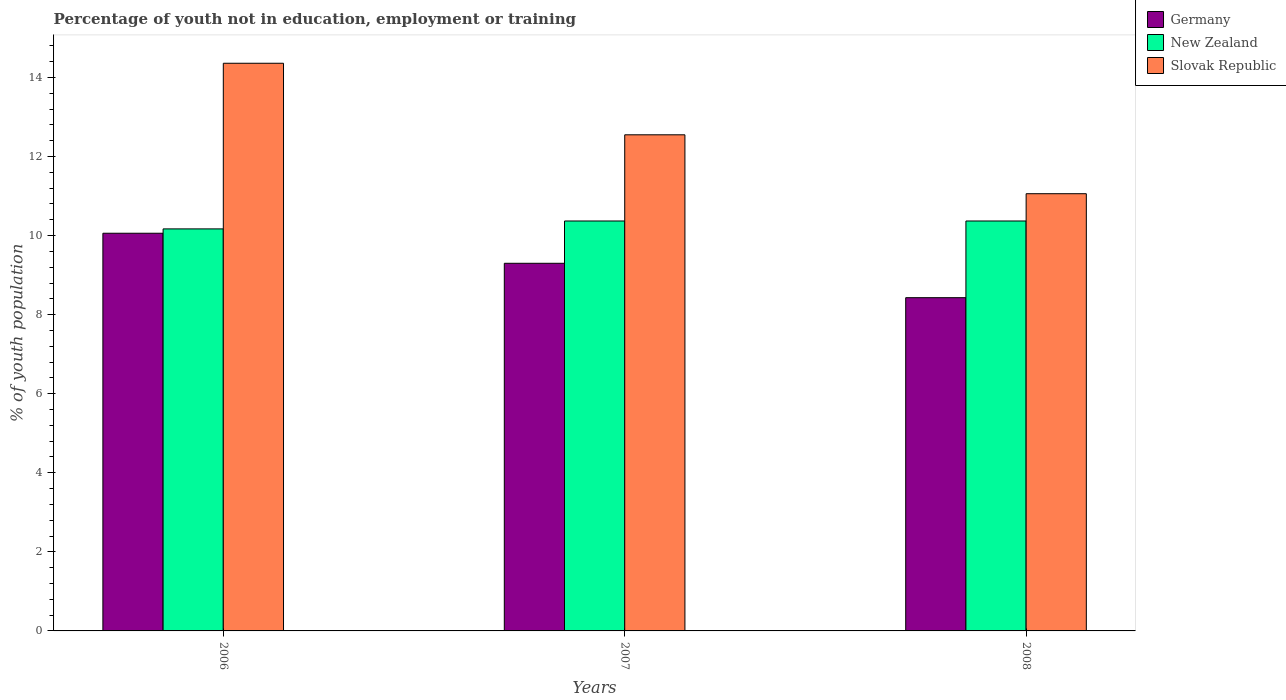How many different coloured bars are there?
Ensure brevity in your answer.  3. How many groups of bars are there?
Ensure brevity in your answer.  3. Are the number of bars per tick equal to the number of legend labels?
Your response must be concise. Yes. Are the number of bars on each tick of the X-axis equal?
Provide a short and direct response. Yes. How many bars are there on the 2nd tick from the right?
Keep it short and to the point. 3. What is the label of the 2nd group of bars from the left?
Your response must be concise. 2007. In how many cases, is the number of bars for a given year not equal to the number of legend labels?
Make the answer very short. 0. What is the percentage of unemployed youth population in in Germany in 2006?
Ensure brevity in your answer.  10.06. Across all years, what is the maximum percentage of unemployed youth population in in Germany?
Offer a very short reply. 10.06. Across all years, what is the minimum percentage of unemployed youth population in in Slovak Republic?
Offer a terse response. 11.06. What is the total percentage of unemployed youth population in in Germany in the graph?
Your response must be concise. 27.79. What is the difference between the percentage of unemployed youth population in in New Zealand in 2007 and that in 2008?
Keep it short and to the point. 0. What is the difference between the percentage of unemployed youth population in in Germany in 2008 and the percentage of unemployed youth population in in New Zealand in 2006?
Provide a short and direct response. -1.74. What is the average percentage of unemployed youth population in in Slovak Republic per year?
Your answer should be compact. 12.66. In the year 2008, what is the difference between the percentage of unemployed youth population in in Germany and percentage of unemployed youth population in in Slovak Republic?
Your answer should be compact. -2.63. What is the ratio of the percentage of unemployed youth population in in New Zealand in 2007 to that in 2008?
Provide a short and direct response. 1. Is the difference between the percentage of unemployed youth population in in Germany in 2007 and 2008 greater than the difference between the percentage of unemployed youth population in in Slovak Republic in 2007 and 2008?
Your answer should be compact. No. What is the difference between the highest and the second highest percentage of unemployed youth population in in Slovak Republic?
Your response must be concise. 1.81. What is the difference between the highest and the lowest percentage of unemployed youth population in in Slovak Republic?
Your answer should be very brief. 3.3. In how many years, is the percentage of unemployed youth population in in New Zealand greater than the average percentage of unemployed youth population in in New Zealand taken over all years?
Keep it short and to the point. 2. What does the 2nd bar from the left in 2006 represents?
Keep it short and to the point. New Zealand. What does the 2nd bar from the right in 2006 represents?
Give a very brief answer. New Zealand. Is it the case that in every year, the sum of the percentage of unemployed youth population in in New Zealand and percentage of unemployed youth population in in Germany is greater than the percentage of unemployed youth population in in Slovak Republic?
Provide a succinct answer. Yes. Are all the bars in the graph horizontal?
Ensure brevity in your answer.  No. Are the values on the major ticks of Y-axis written in scientific E-notation?
Keep it short and to the point. No. Does the graph contain any zero values?
Keep it short and to the point. No. Does the graph contain grids?
Provide a succinct answer. No. Where does the legend appear in the graph?
Give a very brief answer. Top right. How many legend labels are there?
Provide a short and direct response. 3. What is the title of the graph?
Your answer should be compact. Percentage of youth not in education, employment or training. What is the label or title of the Y-axis?
Offer a terse response. % of youth population. What is the % of youth population in Germany in 2006?
Offer a very short reply. 10.06. What is the % of youth population in New Zealand in 2006?
Give a very brief answer. 10.17. What is the % of youth population of Slovak Republic in 2006?
Offer a very short reply. 14.36. What is the % of youth population of Germany in 2007?
Provide a short and direct response. 9.3. What is the % of youth population in New Zealand in 2007?
Provide a succinct answer. 10.37. What is the % of youth population in Slovak Republic in 2007?
Make the answer very short. 12.55. What is the % of youth population in Germany in 2008?
Provide a short and direct response. 8.43. What is the % of youth population of New Zealand in 2008?
Your response must be concise. 10.37. What is the % of youth population in Slovak Republic in 2008?
Offer a terse response. 11.06. Across all years, what is the maximum % of youth population of Germany?
Your answer should be very brief. 10.06. Across all years, what is the maximum % of youth population of New Zealand?
Give a very brief answer. 10.37. Across all years, what is the maximum % of youth population of Slovak Republic?
Provide a short and direct response. 14.36. Across all years, what is the minimum % of youth population of Germany?
Keep it short and to the point. 8.43. Across all years, what is the minimum % of youth population of New Zealand?
Your answer should be compact. 10.17. Across all years, what is the minimum % of youth population of Slovak Republic?
Your answer should be very brief. 11.06. What is the total % of youth population of Germany in the graph?
Offer a very short reply. 27.79. What is the total % of youth population of New Zealand in the graph?
Make the answer very short. 30.91. What is the total % of youth population in Slovak Republic in the graph?
Give a very brief answer. 37.97. What is the difference between the % of youth population in Germany in 2006 and that in 2007?
Offer a terse response. 0.76. What is the difference between the % of youth population of New Zealand in 2006 and that in 2007?
Provide a short and direct response. -0.2. What is the difference between the % of youth population of Slovak Republic in 2006 and that in 2007?
Your answer should be compact. 1.81. What is the difference between the % of youth population in Germany in 2006 and that in 2008?
Give a very brief answer. 1.63. What is the difference between the % of youth population in New Zealand in 2006 and that in 2008?
Ensure brevity in your answer.  -0.2. What is the difference between the % of youth population in Slovak Republic in 2006 and that in 2008?
Your answer should be very brief. 3.3. What is the difference between the % of youth population of Germany in 2007 and that in 2008?
Offer a terse response. 0.87. What is the difference between the % of youth population in New Zealand in 2007 and that in 2008?
Provide a succinct answer. 0. What is the difference between the % of youth population of Slovak Republic in 2007 and that in 2008?
Provide a short and direct response. 1.49. What is the difference between the % of youth population in Germany in 2006 and the % of youth population in New Zealand in 2007?
Provide a short and direct response. -0.31. What is the difference between the % of youth population in Germany in 2006 and the % of youth population in Slovak Republic in 2007?
Your answer should be very brief. -2.49. What is the difference between the % of youth population in New Zealand in 2006 and the % of youth population in Slovak Republic in 2007?
Keep it short and to the point. -2.38. What is the difference between the % of youth population in Germany in 2006 and the % of youth population in New Zealand in 2008?
Give a very brief answer. -0.31. What is the difference between the % of youth population of New Zealand in 2006 and the % of youth population of Slovak Republic in 2008?
Your response must be concise. -0.89. What is the difference between the % of youth population in Germany in 2007 and the % of youth population in New Zealand in 2008?
Provide a succinct answer. -1.07. What is the difference between the % of youth population of Germany in 2007 and the % of youth population of Slovak Republic in 2008?
Provide a short and direct response. -1.76. What is the difference between the % of youth population in New Zealand in 2007 and the % of youth population in Slovak Republic in 2008?
Offer a very short reply. -0.69. What is the average % of youth population of Germany per year?
Offer a terse response. 9.26. What is the average % of youth population in New Zealand per year?
Ensure brevity in your answer.  10.3. What is the average % of youth population in Slovak Republic per year?
Offer a terse response. 12.66. In the year 2006, what is the difference between the % of youth population of Germany and % of youth population of New Zealand?
Offer a very short reply. -0.11. In the year 2006, what is the difference between the % of youth population in Germany and % of youth population in Slovak Republic?
Make the answer very short. -4.3. In the year 2006, what is the difference between the % of youth population in New Zealand and % of youth population in Slovak Republic?
Offer a very short reply. -4.19. In the year 2007, what is the difference between the % of youth population in Germany and % of youth population in New Zealand?
Your response must be concise. -1.07. In the year 2007, what is the difference between the % of youth population in Germany and % of youth population in Slovak Republic?
Ensure brevity in your answer.  -3.25. In the year 2007, what is the difference between the % of youth population in New Zealand and % of youth population in Slovak Republic?
Your answer should be compact. -2.18. In the year 2008, what is the difference between the % of youth population in Germany and % of youth population in New Zealand?
Provide a succinct answer. -1.94. In the year 2008, what is the difference between the % of youth population in Germany and % of youth population in Slovak Republic?
Ensure brevity in your answer.  -2.63. In the year 2008, what is the difference between the % of youth population of New Zealand and % of youth population of Slovak Republic?
Your response must be concise. -0.69. What is the ratio of the % of youth population of Germany in 2006 to that in 2007?
Your answer should be very brief. 1.08. What is the ratio of the % of youth population of New Zealand in 2006 to that in 2007?
Offer a terse response. 0.98. What is the ratio of the % of youth population in Slovak Republic in 2006 to that in 2007?
Make the answer very short. 1.14. What is the ratio of the % of youth population in Germany in 2006 to that in 2008?
Give a very brief answer. 1.19. What is the ratio of the % of youth population in New Zealand in 2006 to that in 2008?
Provide a succinct answer. 0.98. What is the ratio of the % of youth population in Slovak Republic in 2006 to that in 2008?
Offer a terse response. 1.3. What is the ratio of the % of youth population of Germany in 2007 to that in 2008?
Provide a short and direct response. 1.1. What is the ratio of the % of youth population in Slovak Republic in 2007 to that in 2008?
Keep it short and to the point. 1.13. What is the difference between the highest and the second highest % of youth population in Germany?
Offer a terse response. 0.76. What is the difference between the highest and the second highest % of youth population of New Zealand?
Offer a terse response. 0. What is the difference between the highest and the second highest % of youth population in Slovak Republic?
Your response must be concise. 1.81. What is the difference between the highest and the lowest % of youth population in Germany?
Ensure brevity in your answer.  1.63. What is the difference between the highest and the lowest % of youth population in New Zealand?
Make the answer very short. 0.2. 